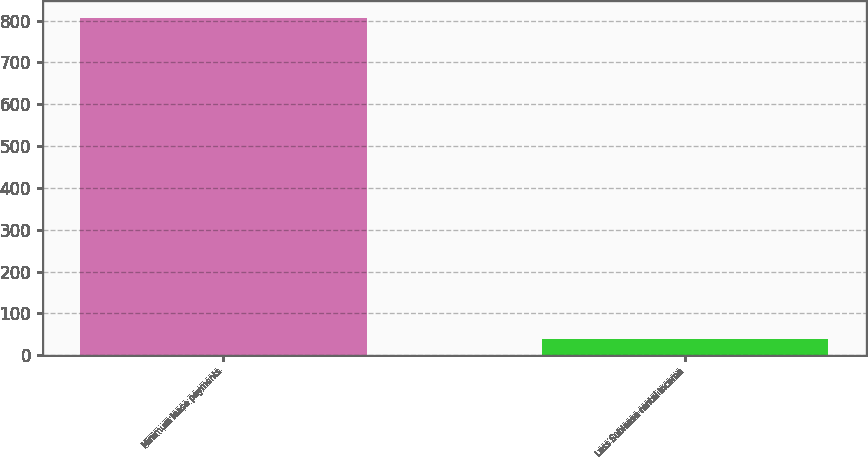<chart> <loc_0><loc_0><loc_500><loc_500><bar_chart><fcel>Minimum lease payments<fcel>Less Sublease rental income<nl><fcel>807<fcel>39<nl></chart> 